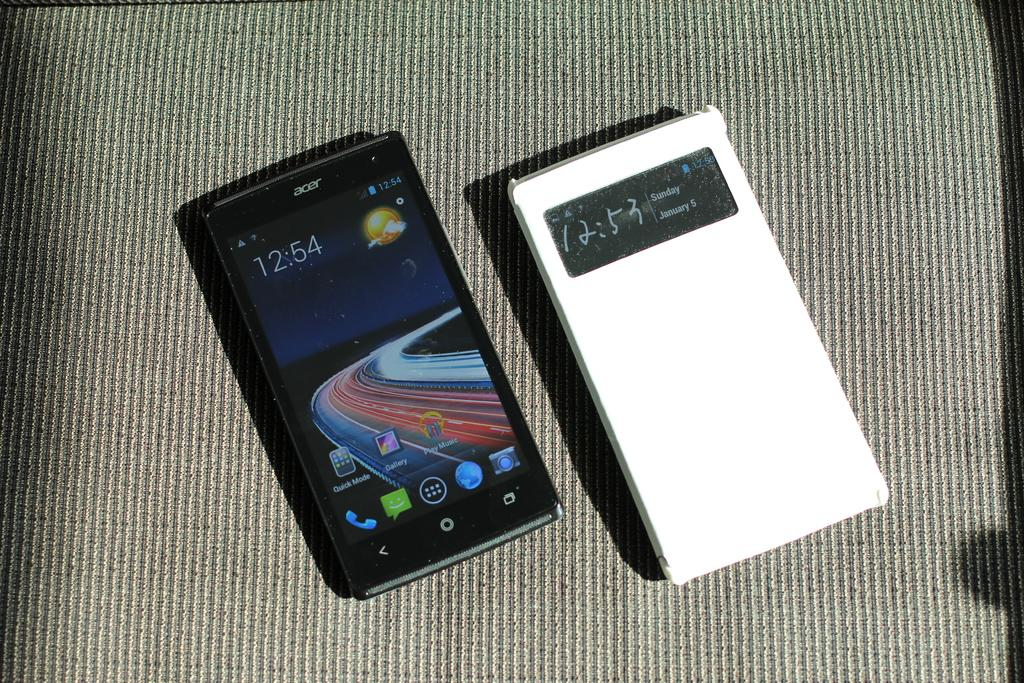Provide a one-sentence caption for the provided image. a small black phone that reads 12:54 on it. 